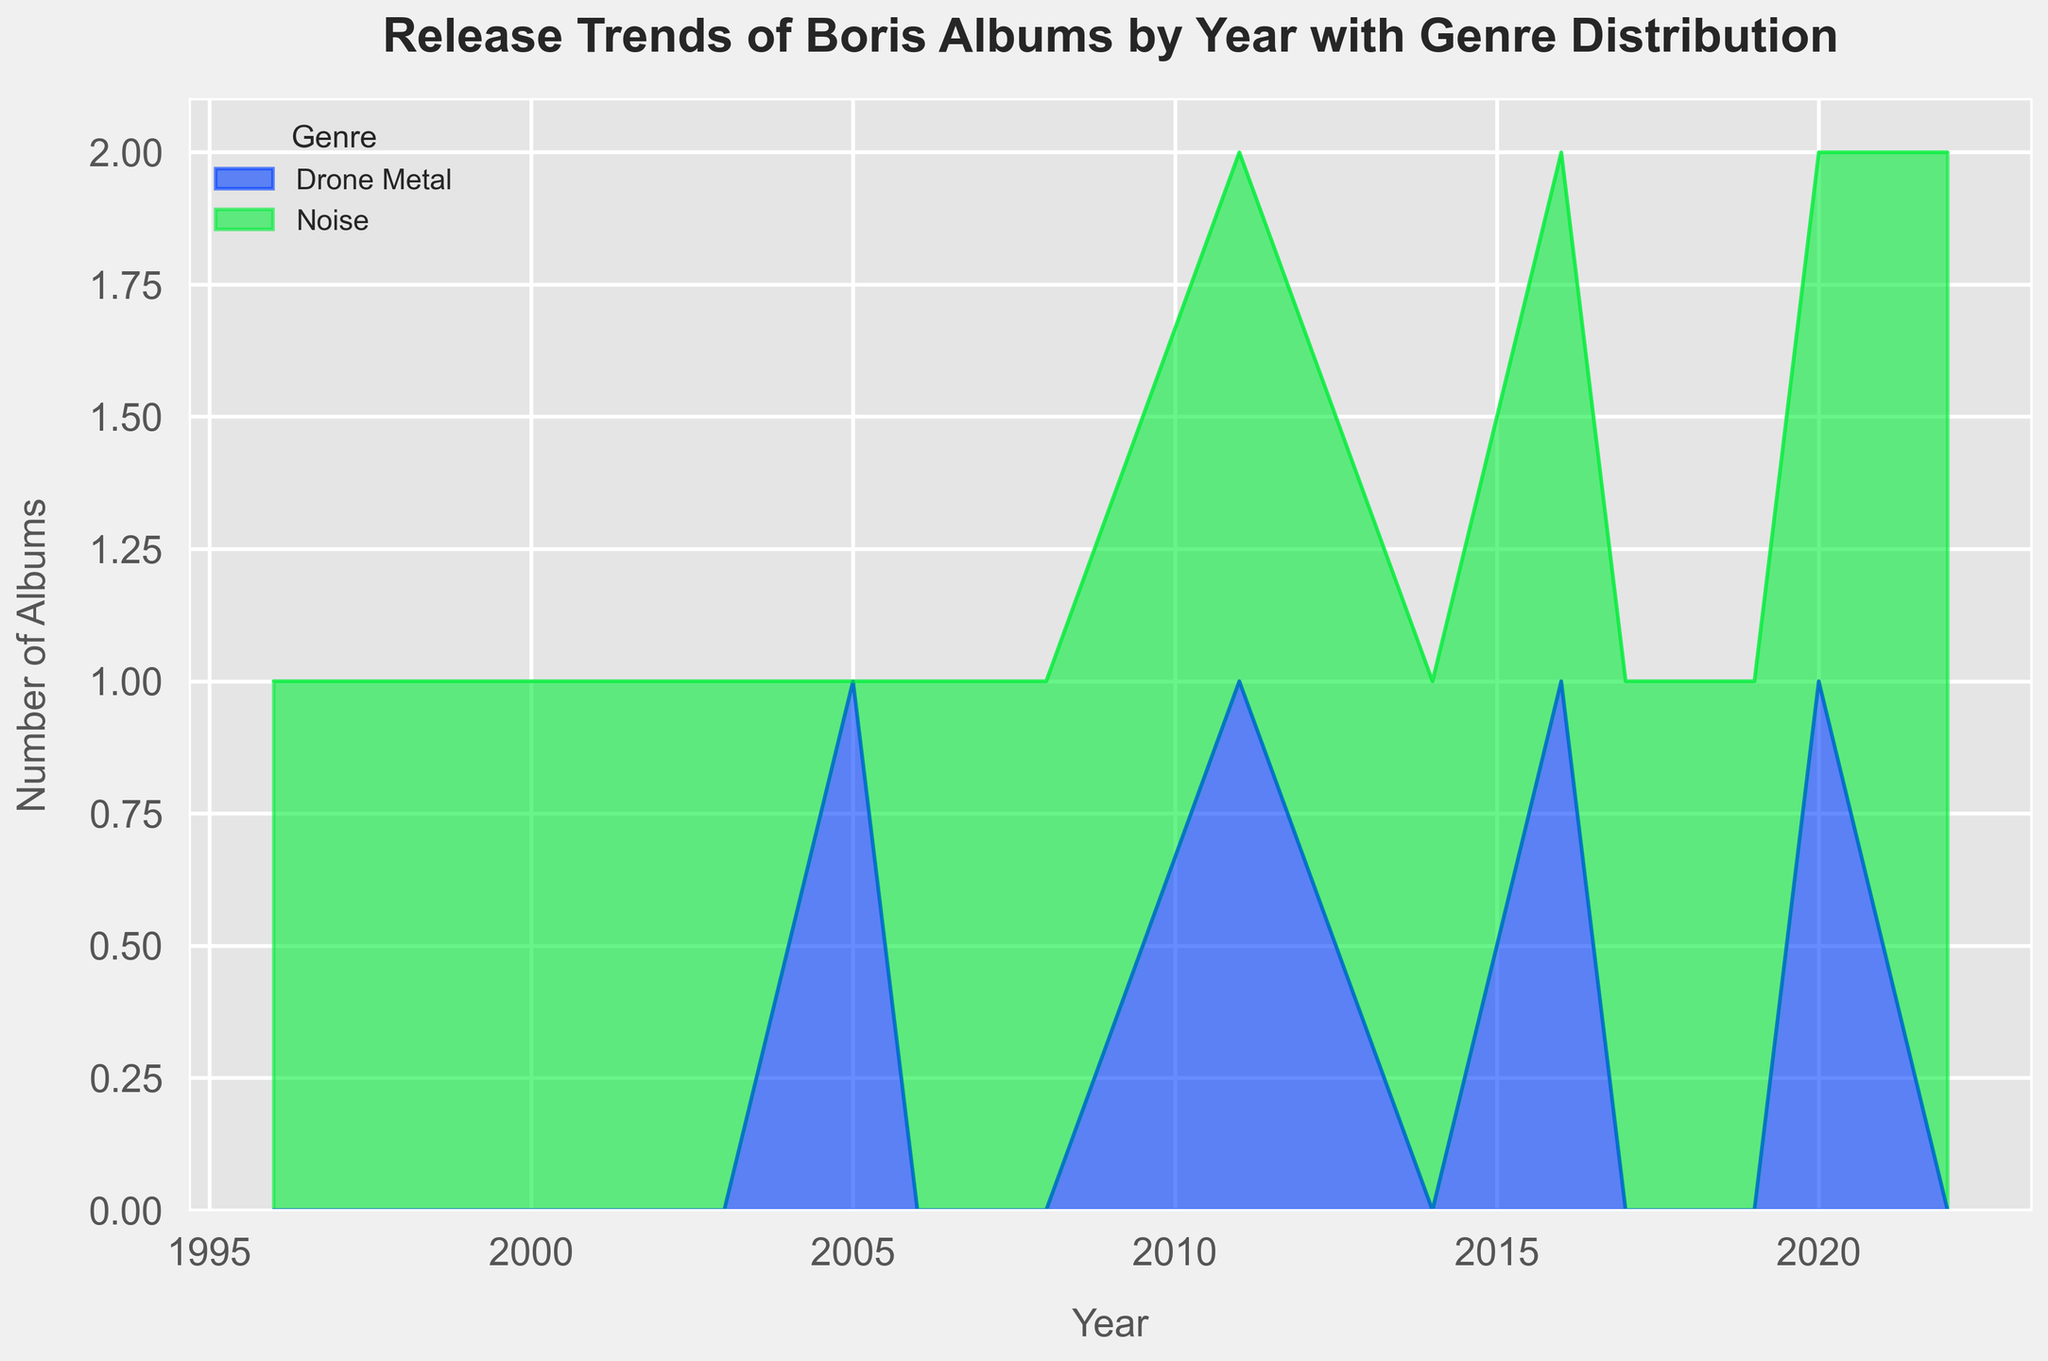What year did Boris release the most albums? Looking at the peaks in the area chart, the year with the highest number of albums is 2022.
Answer: 2022 In which years did Boris release both Noise and Drone Metal albums? Checking the area chart, we see two highlighted areas (representing Noise and Drone Metal) in 2011, 2016, and 2020.
Answer: 2011, 2016, 2020 Which genre saw the most consistent annual releases? The Noise genre shows a presence across almost every year without large gaps, indicating consistency.
Answer: Noise How many total albums did Boris release between 1996 and 2022? Summing up the individual values from the chart: 1 (1996) + 1 (1998) + 1(2000) + 1 (2002) + 1(2003) + 1(2005) + 1(2006) + 1(2008) + 2(2011) + 1(2014) + 2(2016) + 1(2017) + 1(2019) + 2(2020) + 2(2022) = 19 albums.
Answer: 19 In terms of genre distribution, which genre shows a sudden increase in releases in any specific year? By observing the expansions in both areas, Noise genre shows an increase in 2022 with 2 albums released compared to its usual pattern.
Answer: Noise in 2022 Which time period saw the longest gap without any releases? The area chart shows no albums between 1988 and 1996, indicating the longest gap.
Answer: 1988-1996 How many Noise albums were released after 2010? Summing the Noise entries from 2011 onward: 1(2011) + 1(2014) + 1(2016) + 1(2017) + 1(2019) + 1(2020) + 2(2022) = 8 albums.
Answer: 8 